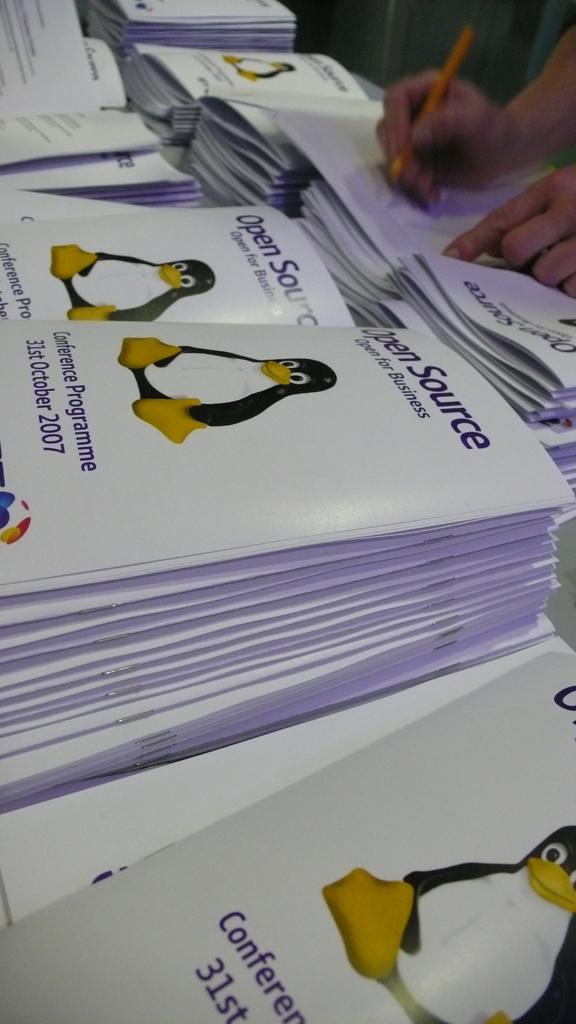What objects can be seen in the image? There are books and a person in the image. What is the person doing in the image? The person is writing on a paper. Where can the bead be found in the image? There is no bead present in the image. What type of thrill can be experienced by the person in the image? The image does not provide information about the person's emotions or experiences, so it cannot be determined if they are experiencing any thrill. 